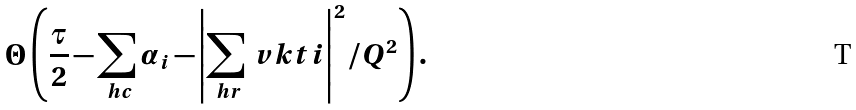<formula> <loc_0><loc_0><loc_500><loc_500>\Theta \left ( \frac { \tau } { 2 } - \sum _ { \ h c } \alpha _ { i } - \left | \sum _ { \ h r } \ v k t i \right | ^ { 2 } / Q ^ { 2 } \right ) .</formula> 